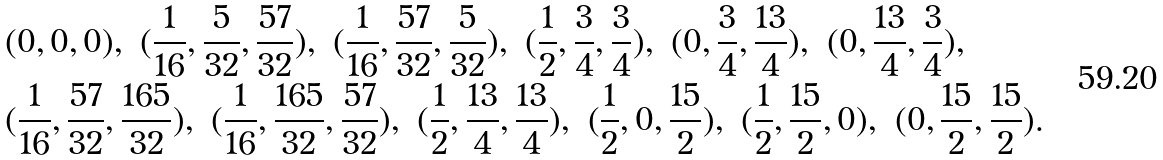<formula> <loc_0><loc_0><loc_500><loc_500>& ( 0 , 0 , 0 ) , \ ( \frac { 1 } { 1 6 } , \frac { 5 } { 3 2 } , \frac { 5 7 } { 3 2 } ) , \ ( \frac { 1 } { 1 6 } , \frac { 5 7 } { 3 2 } , \frac { 5 } { 3 2 } ) , \ ( \frac { 1 } 2 , \frac { 3 } 4 , \frac { 3 } 4 ) , \ ( 0 , \frac { 3 } 4 , \frac { 1 3 } 4 ) , \ ( 0 , \frac { 1 3 } 4 , \frac { 3 } 4 ) , \\ & ( \frac { 1 } { 1 6 } , \frac { 5 7 } { 3 2 } , \frac { 1 6 5 } { 3 2 } ) , \ ( \frac { 1 } { 1 6 } , \frac { 1 6 5 } { 3 2 } , \frac { 5 7 } { 3 2 } ) , \ ( \frac { 1 } 2 , \frac { 1 3 } 4 , \frac { 1 3 } 4 ) , \ ( \frac { 1 } 2 , 0 , \frac { 1 5 } 2 ) , \ ( \frac { 1 } 2 , \frac { 1 5 } 2 , 0 ) , \ ( 0 , \frac { 1 5 } 2 , \frac { 1 5 } 2 ) .</formula> 